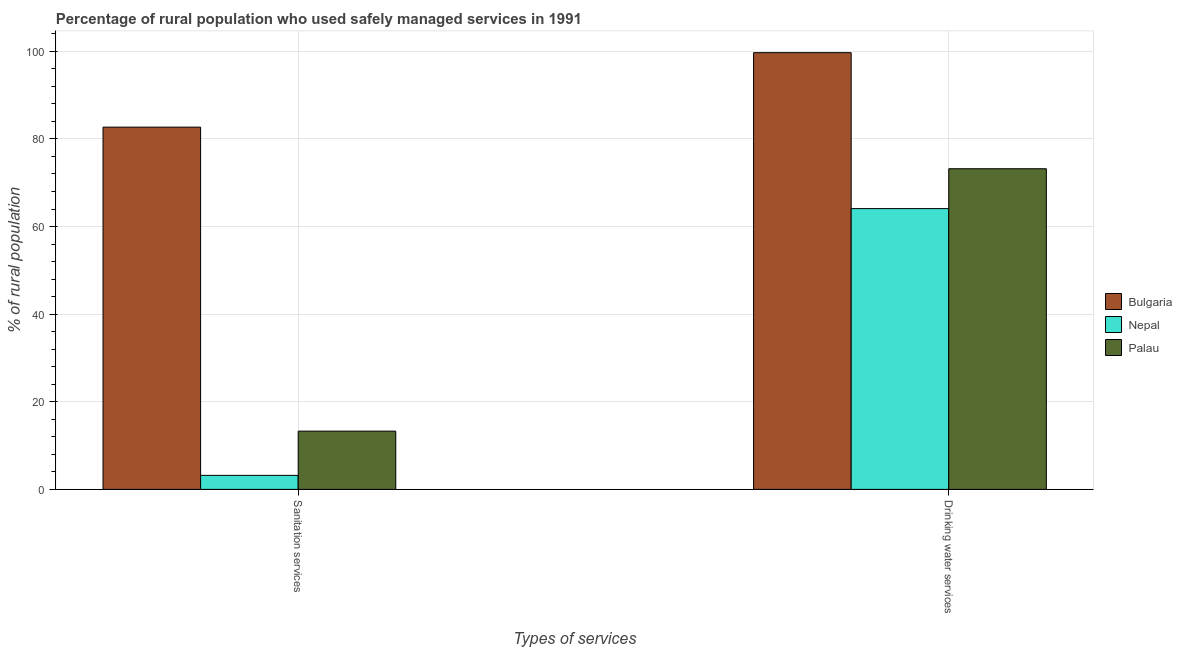How many different coloured bars are there?
Provide a short and direct response. 3. How many groups of bars are there?
Provide a succinct answer. 2. Are the number of bars per tick equal to the number of legend labels?
Your answer should be very brief. Yes. How many bars are there on the 1st tick from the left?
Your answer should be compact. 3. How many bars are there on the 2nd tick from the right?
Keep it short and to the point. 3. What is the label of the 1st group of bars from the left?
Ensure brevity in your answer.  Sanitation services. What is the percentage of rural population who used drinking water services in Palau?
Keep it short and to the point. 73.2. Across all countries, what is the maximum percentage of rural population who used drinking water services?
Provide a short and direct response. 99.7. In which country was the percentage of rural population who used drinking water services minimum?
Your response must be concise. Nepal. What is the total percentage of rural population who used drinking water services in the graph?
Keep it short and to the point. 237. What is the difference between the percentage of rural population who used drinking water services in Bulgaria and that in Palau?
Provide a succinct answer. 26.5. What is the difference between the percentage of rural population who used sanitation services in Nepal and the percentage of rural population who used drinking water services in Palau?
Make the answer very short. -70. What is the average percentage of rural population who used drinking water services per country?
Provide a succinct answer. 79. What is the difference between the percentage of rural population who used sanitation services and percentage of rural population who used drinking water services in Palau?
Keep it short and to the point. -59.9. What is the ratio of the percentage of rural population who used drinking water services in Bulgaria to that in Nepal?
Provide a short and direct response. 1.56. What does the 3rd bar from the left in Drinking water services represents?
Ensure brevity in your answer.  Palau. Are all the bars in the graph horizontal?
Ensure brevity in your answer.  No. Does the graph contain grids?
Provide a succinct answer. Yes. How many legend labels are there?
Keep it short and to the point. 3. What is the title of the graph?
Your answer should be compact. Percentage of rural population who used safely managed services in 1991. Does "St. Kitts and Nevis" appear as one of the legend labels in the graph?
Offer a very short reply. No. What is the label or title of the X-axis?
Your answer should be compact. Types of services. What is the label or title of the Y-axis?
Your answer should be very brief. % of rural population. What is the % of rural population in Bulgaria in Sanitation services?
Your answer should be very brief. 82.7. What is the % of rural population of Palau in Sanitation services?
Give a very brief answer. 13.3. What is the % of rural population in Bulgaria in Drinking water services?
Your response must be concise. 99.7. What is the % of rural population of Nepal in Drinking water services?
Your response must be concise. 64.1. What is the % of rural population in Palau in Drinking water services?
Provide a short and direct response. 73.2. Across all Types of services, what is the maximum % of rural population of Bulgaria?
Give a very brief answer. 99.7. Across all Types of services, what is the maximum % of rural population of Nepal?
Ensure brevity in your answer.  64.1. Across all Types of services, what is the maximum % of rural population in Palau?
Your response must be concise. 73.2. Across all Types of services, what is the minimum % of rural population in Bulgaria?
Offer a very short reply. 82.7. What is the total % of rural population of Bulgaria in the graph?
Keep it short and to the point. 182.4. What is the total % of rural population in Nepal in the graph?
Make the answer very short. 67.3. What is the total % of rural population of Palau in the graph?
Offer a very short reply. 86.5. What is the difference between the % of rural population in Nepal in Sanitation services and that in Drinking water services?
Ensure brevity in your answer.  -60.9. What is the difference between the % of rural population in Palau in Sanitation services and that in Drinking water services?
Your answer should be very brief. -59.9. What is the difference between the % of rural population in Bulgaria in Sanitation services and the % of rural population in Nepal in Drinking water services?
Ensure brevity in your answer.  18.6. What is the difference between the % of rural population in Bulgaria in Sanitation services and the % of rural population in Palau in Drinking water services?
Your answer should be compact. 9.5. What is the difference between the % of rural population of Nepal in Sanitation services and the % of rural population of Palau in Drinking water services?
Your answer should be very brief. -70. What is the average % of rural population of Bulgaria per Types of services?
Give a very brief answer. 91.2. What is the average % of rural population in Nepal per Types of services?
Offer a very short reply. 33.65. What is the average % of rural population in Palau per Types of services?
Offer a very short reply. 43.25. What is the difference between the % of rural population in Bulgaria and % of rural population in Nepal in Sanitation services?
Your answer should be very brief. 79.5. What is the difference between the % of rural population of Bulgaria and % of rural population of Palau in Sanitation services?
Provide a succinct answer. 69.4. What is the difference between the % of rural population of Bulgaria and % of rural population of Nepal in Drinking water services?
Offer a very short reply. 35.6. What is the difference between the % of rural population of Bulgaria and % of rural population of Palau in Drinking water services?
Offer a terse response. 26.5. What is the difference between the % of rural population of Nepal and % of rural population of Palau in Drinking water services?
Keep it short and to the point. -9.1. What is the ratio of the % of rural population of Bulgaria in Sanitation services to that in Drinking water services?
Your answer should be very brief. 0.83. What is the ratio of the % of rural population of Nepal in Sanitation services to that in Drinking water services?
Your answer should be compact. 0.05. What is the ratio of the % of rural population of Palau in Sanitation services to that in Drinking water services?
Provide a short and direct response. 0.18. What is the difference between the highest and the second highest % of rural population in Nepal?
Your response must be concise. 60.9. What is the difference between the highest and the second highest % of rural population of Palau?
Your answer should be very brief. 59.9. What is the difference between the highest and the lowest % of rural population in Bulgaria?
Keep it short and to the point. 17. What is the difference between the highest and the lowest % of rural population of Nepal?
Your answer should be compact. 60.9. What is the difference between the highest and the lowest % of rural population in Palau?
Your response must be concise. 59.9. 